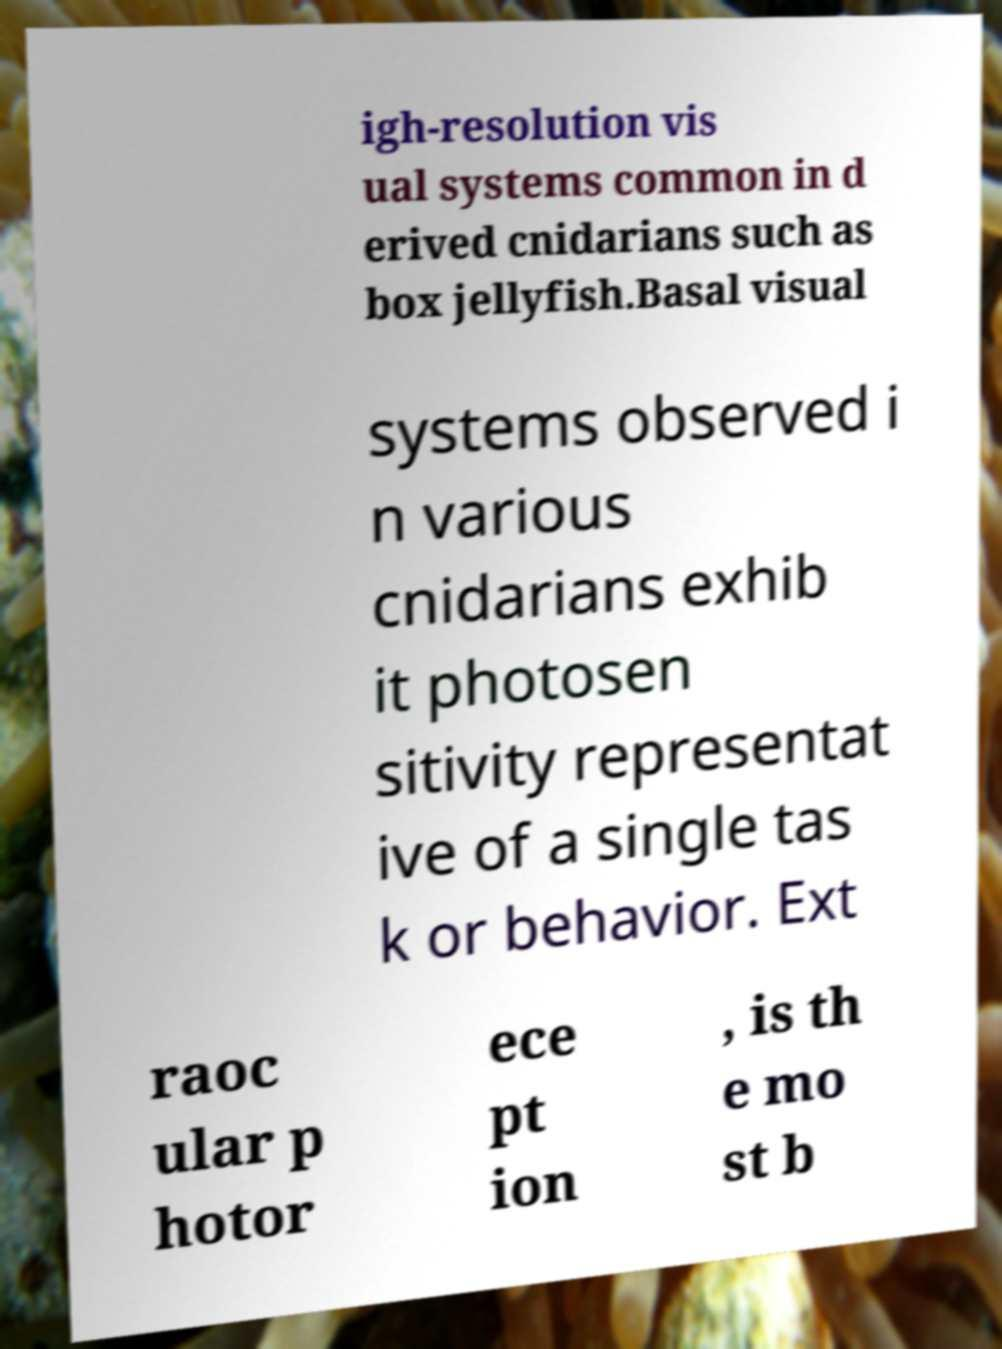For documentation purposes, I need the text within this image transcribed. Could you provide that? igh-resolution vis ual systems common in d erived cnidarians such as box jellyfish.Basal visual systems observed i n various cnidarians exhib it photosen sitivity representat ive of a single tas k or behavior. Ext raoc ular p hotor ece pt ion , is th e mo st b 